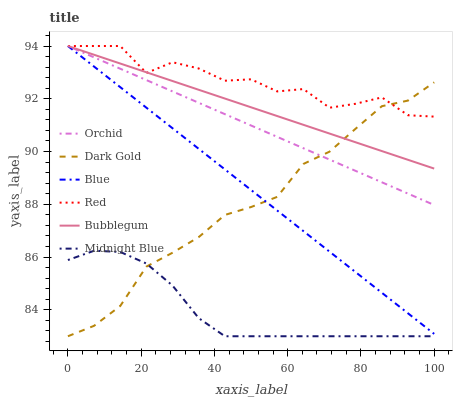Does Midnight Blue have the minimum area under the curve?
Answer yes or no. Yes. Does Red have the maximum area under the curve?
Answer yes or no. Yes. Does Dark Gold have the minimum area under the curve?
Answer yes or no. No. Does Dark Gold have the maximum area under the curve?
Answer yes or no. No. Is Orchid the smoothest?
Answer yes or no. Yes. Is Red the roughest?
Answer yes or no. Yes. Is Midnight Blue the smoothest?
Answer yes or no. No. Is Midnight Blue the roughest?
Answer yes or no. No. Does Midnight Blue have the lowest value?
Answer yes or no. Yes. Does Bubblegum have the lowest value?
Answer yes or no. No. Does Orchid have the highest value?
Answer yes or no. Yes. Does Dark Gold have the highest value?
Answer yes or no. No. Is Midnight Blue less than Blue?
Answer yes or no. Yes. Is Orchid greater than Midnight Blue?
Answer yes or no. Yes. Does Bubblegum intersect Orchid?
Answer yes or no. Yes. Is Bubblegum less than Orchid?
Answer yes or no. No. Is Bubblegum greater than Orchid?
Answer yes or no. No. Does Midnight Blue intersect Blue?
Answer yes or no. No. 